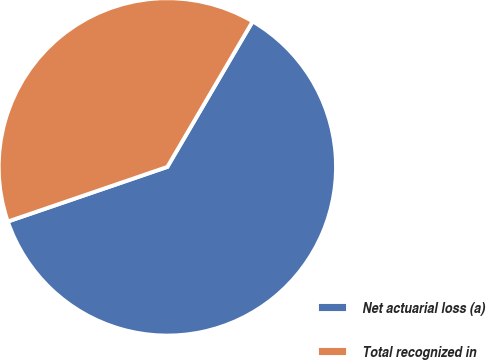Convert chart to OTSL. <chart><loc_0><loc_0><loc_500><loc_500><pie_chart><fcel>Net actuarial loss (a)<fcel>Total recognized in<nl><fcel>61.31%<fcel>38.69%<nl></chart> 